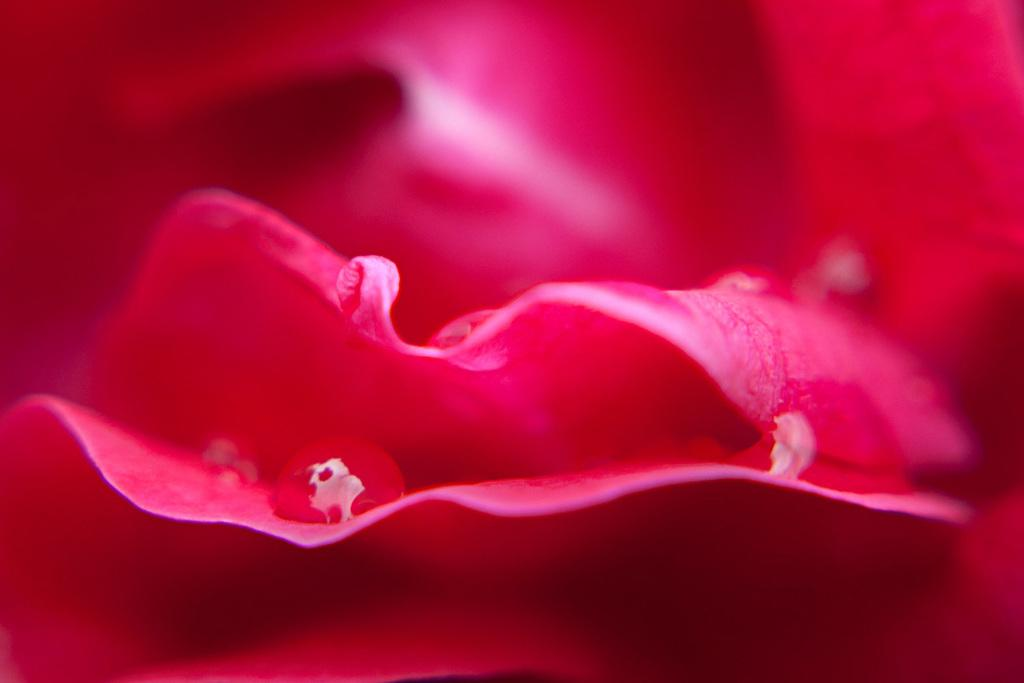What is present on the flower foils in the image? There are water drops on the flower foils in the image. What color are the flower foils? The flower foils are pink in color. How would you describe the background of the image? The background of the image is blurred. How many porters are assisting with the luggage at the station in the image? There is no station or luggage present in the image; it features flower foils with water drops and a blurred background. 